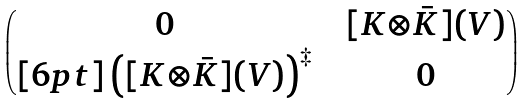Convert formula to latex. <formula><loc_0><loc_0><loc_500><loc_500>\begin{pmatrix} 0 & & [ K { \otimes } \bar { K } ] ( V ) \\ [ 6 p t ] \left ( [ K { \otimes } \bar { K } ] ( V ) \right ) ^ { \ddag } & & 0 \end{pmatrix}</formula> 